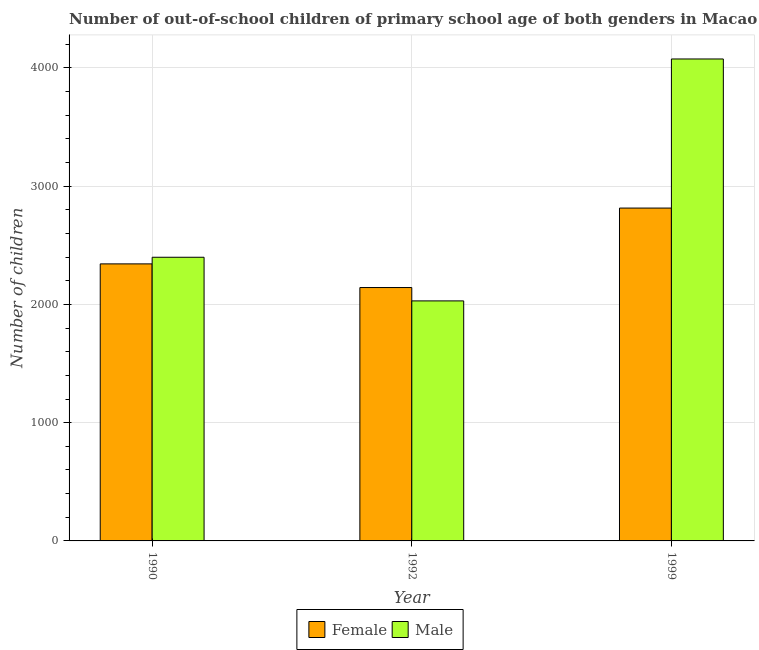How many groups of bars are there?
Offer a very short reply. 3. How many bars are there on the 2nd tick from the left?
Provide a short and direct response. 2. How many bars are there on the 1st tick from the right?
Give a very brief answer. 2. In how many cases, is the number of bars for a given year not equal to the number of legend labels?
Provide a short and direct response. 0. What is the number of female out-of-school students in 1990?
Keep it short and to the point. 2343. Across all years, what is the maximum number of male out-of-school students?
Ensure brevity in your answer.  4076. Across all years, what is the minimum number of female out-of-school students?
Keep it short and to the point. 2143. In which year was the number of male out-of-school students maximum?
Keep it short and to the point. 1999. What is the total number of male out-of-school students in the graph?
Offer a very short reply. 8505. What is the difference between the number of male out-of-school students in 1990 and that in 1999?
Provide a short and direct response. -1677. What is the difference between the number of male out-of-school students in 1992 and the number of female out-of-school students in 1999?
Make the answer very short. -2046. What is the average number of female out-of-school students per year?
Your answer should be very brief. 2433.67. In the year 1992, what is the difference between the number of male out-of-school students and number of female out-of-school students?
Your answer should be compact. 0. In how many years, is the number of male out-of-school students greater than 2800?
Your answer should be very brief. 1. What is the ratio of the number of male out-of-school students in 1990 to that in 1992?
Your answer should be compact. 1.18. What is the difference between the highest and the second highest number of male out-of-school students?
Give a very brief answer. 1677. What is the difference between the highest and the lowest number of female out-of-school students?
Keep it short and to the point. 672. In how many years, is the number of male out-of-school students greater than the average number of male out-of-school students taken over all years?
Offer a very short reply. 1. Is the sum of the number of male out-of-school students in 1990 and 1992 greater than the maximum number of female out-of-school students across all years?
Provide a short and direct response. Yes. What does the 1st bar from the left in 1992 represents?
Your response must be concise. Female. How many bars are there?
Provide a short and direct response. 6. Are all the bars in the graph horizontal?
Provide a succinct answer. No. What is the difference between two consecutive major ticks on the Y-axis?
Give a very brief answer. 1000. Are the values on the major ticks of Y-axis written in scientific E-notation?
Make the answer very short. No. Where does the legend appear in the graph?
Keep it short and to the point. Bottom center. How many legend labels are there?
Make the answer very short. 2. How are the legend labels stacked?
Offer a terse response. Horizontal. What is the title of the graph?
Offer a very short reply. Number of out-of-school children of primary school age of both genders in Macao. Does "Register a business" appear as one of the legend labels in the graph?
Provide a short and direct response. No. What is the label or title of the Y-axis?
Your response must be concise. Number of children. What is the Number of children of Female in 1990?
Give a very brief answer. 2343. What is the Number of children in Male in 1990?
Provide a succinct answer. 2399. What is the Number of children in Female in 1992?
Your answer should be very brief. 2143. What is the Number of children of Male in 1992?
Keep it short and to the point. 2030. What is the Number of children of Female in 1999?
Give a very brief answer. 2815. What is the Number of children in Male in 1999?
Provide a short and direct response. 4076. Across all years, what is the maximum Number of children in Female?
Your answer should be very brief. 2815. Across all years, what is the maximum Number of children of Male?
Offer a terse response. 4076. Across all years, what is the minimum Number of children in Female?
Your answer should be compact. 2143. Across all years, what is the minimum Number of children in Male?
Your answer should be very brief. 2030. What is the total Number of children of Female in the graph?
Make the answer very short. 7301. What is the total Number of children of Male in the graph?
Your response must be concise. 8505. What is the difference between the Number of children in Male in 1990 and that in 1992?
Offer a terse response. 369. What is the difference between the Number of children of Female in 1990 and that in 1999?
Your answer should be compact. -472. What is the difference between the Number of children in Male in 1990 and that in 1999?
Offer a very short reply. -1677. What is the difference between the Number of children in Female in 1992 and that in 1999?
Make the answer very short. -672. What is the difference between the Number of children of Male in 1992 and that in 1999?
Your answer should be very brief. -2046. What is the difference between the Number of children of Female in 1990 and the Number of children of Male in 1992?
Keep it short and to the point. 313. What is the difference between the Number of children in Female in 1990 and the Number of children in Male in 1999?
Provide a short and direct response. -1733. What is the difference between the Number of children in Female in 1992 and the Number of children in Male in 1999?
Your answer should be very brief. -1933. What is the average Number of children of Female per year?
Provide a succinct answer. 2433.67. What is the average Number of children of Male per year?
Your answer should be very brief. 2835. In the year 1990, what is the difference between the Number of children of Female and Number of children of Male?
Give a very brief answer. -56. In the year 1992, what is the difference between the Number of children of Female and Number of children of Male?
Keep it short and to the point. 113. In the year 1999, what is the difference between the Number of children in Female and Number of children in Male?
Provide a succinct answer. -1261. What is the ratio of the Number of children of Female in 1990 to that in 1992?
Provide a succinct answer. 1.09. What is the ratio of the Number of children in Male in 1990 to that in 1992?
Offer a very short reply. 1.18. What is the ratio of the Number of children of Female in 1990 to that in 1999?
Make the answer very short. 0.83. What is the ratio of the Number of children in Male in 1990 to that in 1999?
Give a very brief answer. 0.59. What is the ratio of the Number of children in Female in 1992 to that in 1999?
Provide a succinct answer. 0.76. What is the ratio of the Number of children of Male in 1992 to that in 1999?
Keep it short and to the point. 0.5. What is the difference between the highest and the second highest Number of children in Female?
Offer a very short reply. 472. What is the difference between the highest and the second highest Number of children in Male?
Offer a very short reply. 1677. What is the difference between the highest and the lowest Number of children of Female?
Offer a terse response. 672. What is the difference between the highest and the lowest Number of children of Male?
Make the answer very short. 2046. 